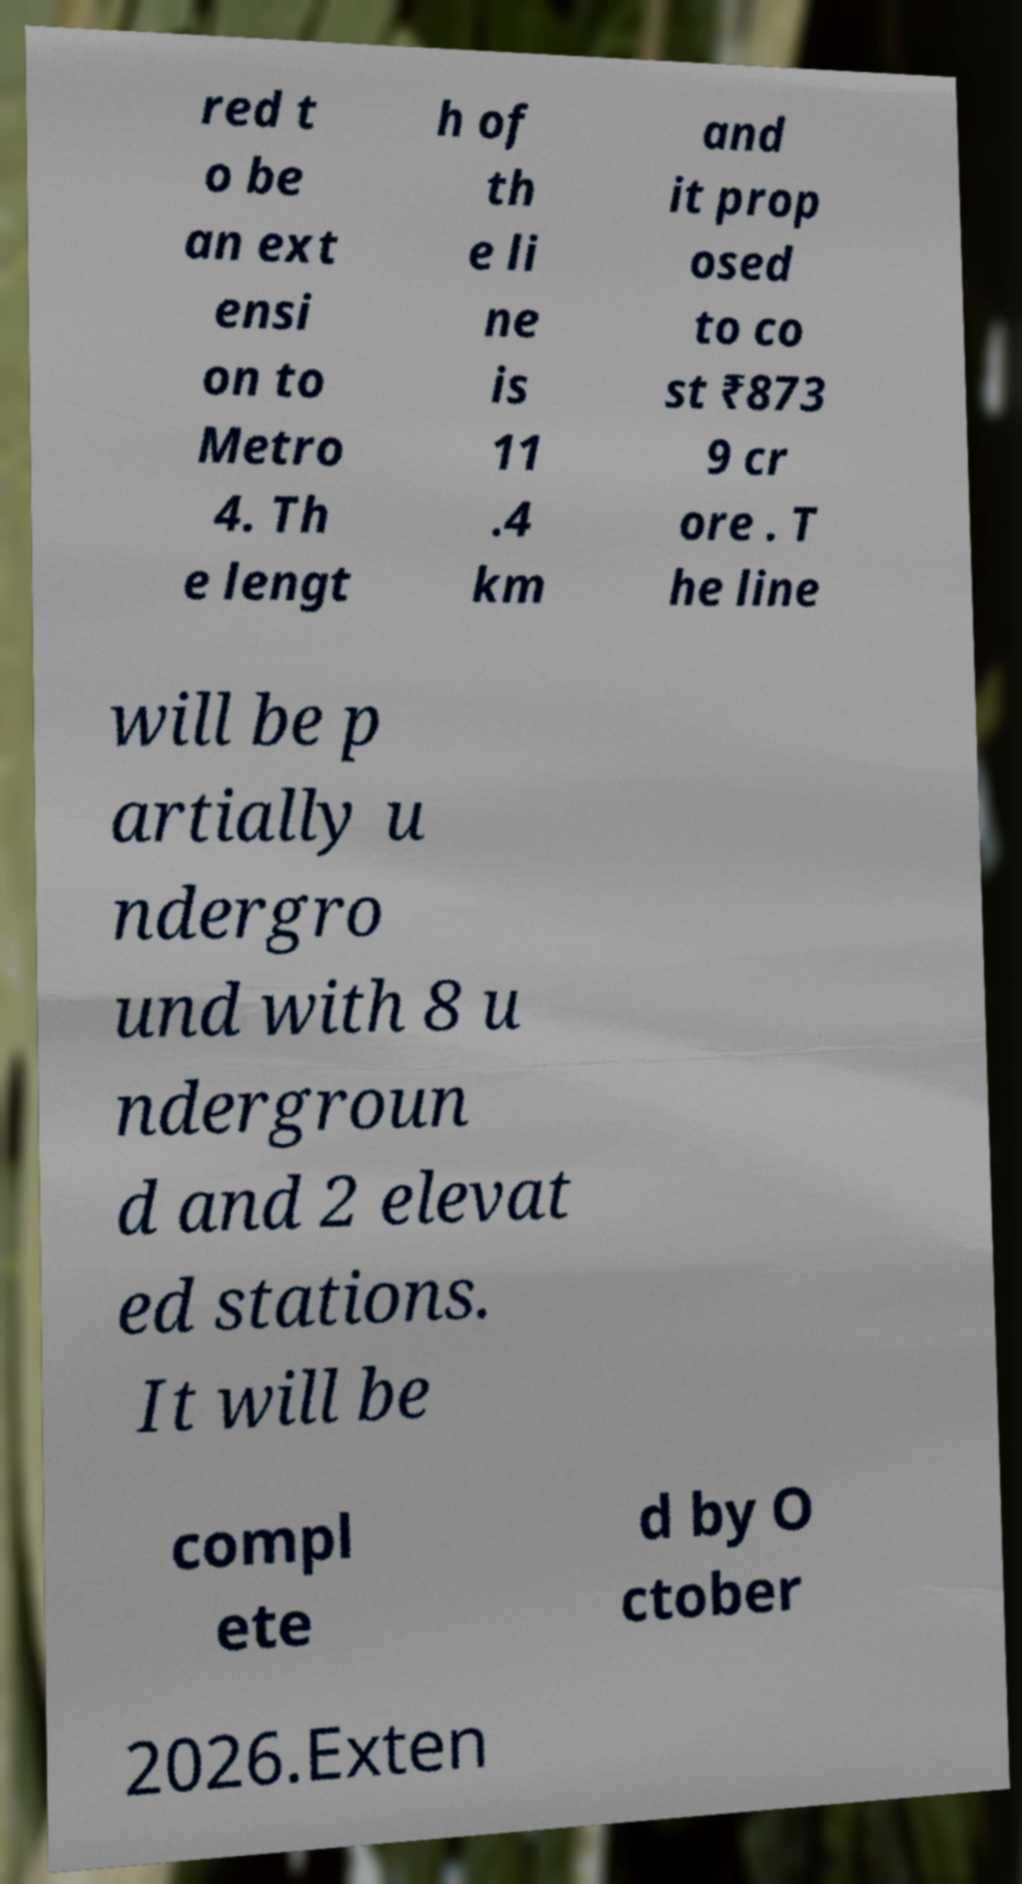Please identify and transcribe the text found in this image. red t o be an ext ensi on to Metro 4. Th e lengt h of th e li ne is 11 .4 km and it prop osed to co st ₹873 9 cr ore . T he line will be p artially u ndergro und with 8 u ndergroun d and 2 elevat ed stations. It will be compl ete d by O ctober 2026.Exten 